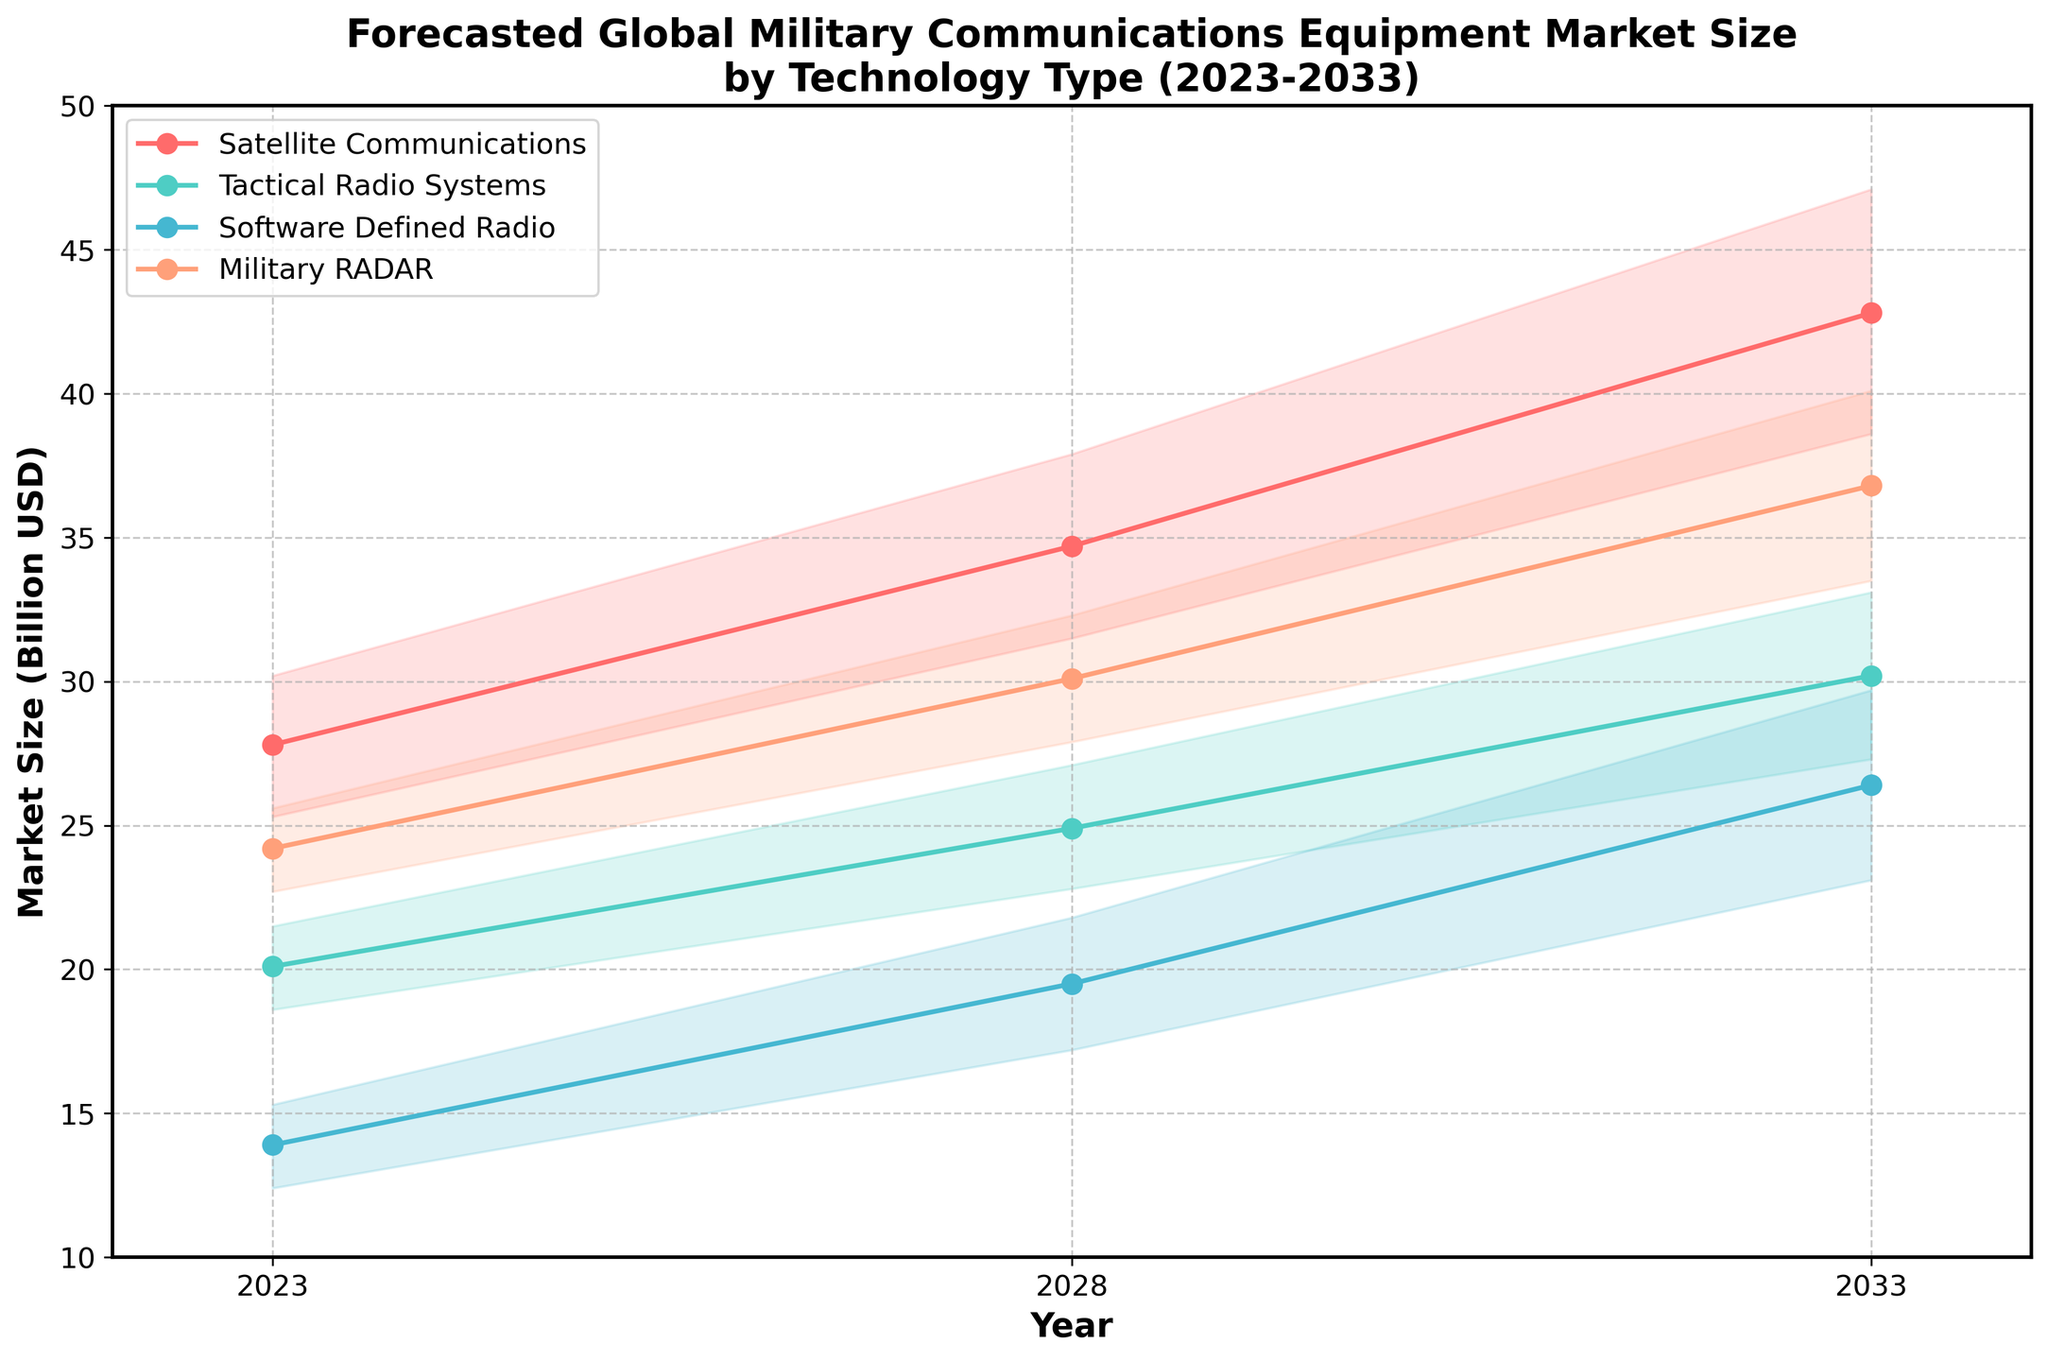What is the title of the plot? The title is located at the top of the plot and provides a summary of what the plot represents. By reading it, we can understand that the plot shows the forecasted global military communications equipment market size from 2023 to 2033, segmented by technology type.
Answer: Forecasted Global Military Communications Equipment Market Size by Technology Type (2023-2033) What are the units used on the y-axis? The label on the y-axis indicates the units used for the market size data. It specifies that the values are in billions of USD.
Answer: Billion USD Which technology type is forecasted to have the highest medium estimate in 2033? Locate the medium estimate values for 2033 on the plot and compare them across all technology types. Satellite Communications has the highest medium estimate in 2033.
Answer: Satellite Communications What is the range of the medium estimate for Tactical Radio Systems from 2023 to 2033? The medium estimate values for Tactical Radio Systems in 2023 and 2033 are plotted, and the range is calculated by finding the difference between these values: 30.2 (2033) - 20.1 (2023).
Answer: 10.1 Billion USD What is the difference between the high and low estimates for Software Defined Radio in 2028? Look at the high and low estimate values for Software Defined Radio in 2028. The difference is calculated by subtracting the low estimate from the high estimate: 21.8 - 17.2.
Answer: 4.6 Billion USD Which technology shows the greatest increase in its medium estimate from 2023 to 2033? Calculate the increase in the medium estimates for each technology from 2023 to 2033 and compare them. The Satellite Communications technology shows the greatest increase: 42.8 - 27.8 = 15.0.
Answer: Satellite Communications Which technology type has the most consistent forecasted growth (smallest difference between high and low estimates) in 2028? Compare the differences between the high and low estimates for all technologies in 2028, and identify the smallest difference. Software Defined Radio has the smallest difference of 4.6.
Answer: Software Defined Radio In which year is the medium estimate for Military RADAR closest to its low estimate? Compare the medium estimate values with their corresponding low estimate values for Military RADAR across all years. The closest pair is in 2023, where the difference between medium (24.2) and low (22.7) is 1.5.
Answer: 2023 By how much does the medium estimate for Software Defined Radio increase from 2023 to 2028? Subtract the medium estimate for Software Defined Radio in 2023 from the medium estimate in 2028: 19.5 - 13.9.
Answer: 5.6 Billion USD 